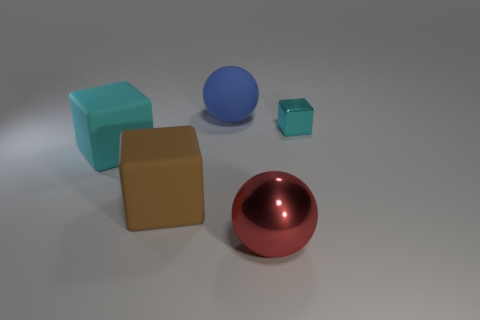Subtract all yellow blocks. Subtract all cyan cylinders. How many blocks are left? 3 Add 2 metal balls. How many objects exist? 7 Subtract all balls. How many objects are left? 3 Subtract 0 gray blocks. How many objects are left? 5 Subtract all metallic blocks. Subtract all green metallic balls. How many objects are left? 4 Add 1 objects. How many objects are left? 6 Add 1 big cubes. How many big cubes exist? 3 